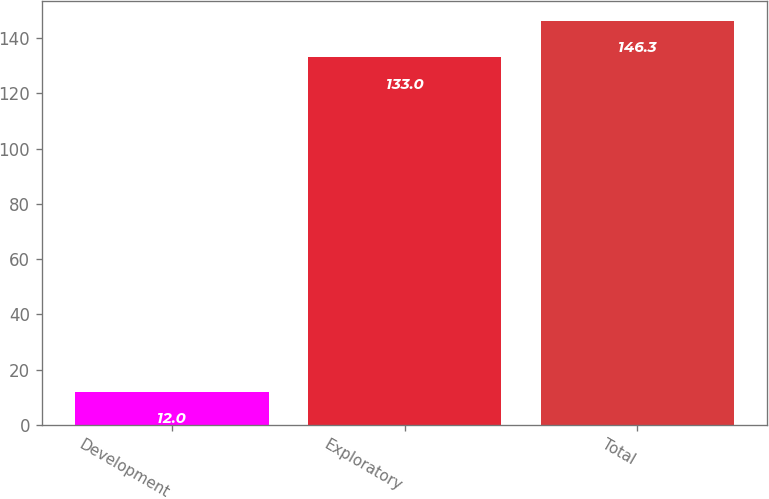Convert chart to OTSL. <chart><loc_0><loc_0><loc_500><loc_500><bar_chart><fcel>Development<fcel>Exploratory<fcel>Total<nl><fcel>12<fcel>133<fcel>146.3<nl></chart> 